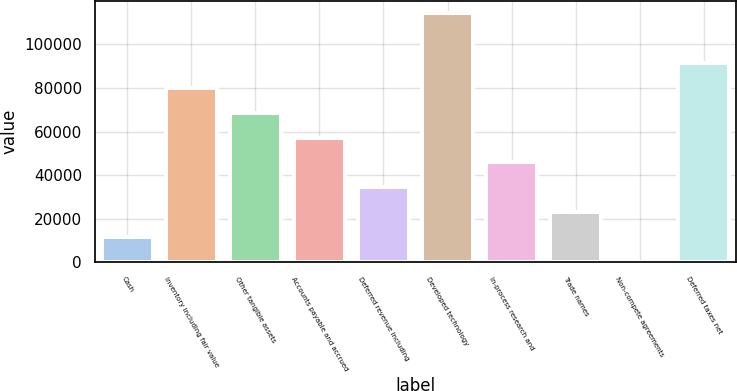Convert chart. <chart><loc_0><loc_0><loc_500><loc_500><bar_chart><fcel>Cash<fcel>Inventory including fair value<fcel>Other tangible assets<fcel>Accounts payable and accrued<fcel>Deferred revenue including<fcel>Developed technology<fcel>In-process research and<fcel>Trade names<fcel>Non-compete agreements<fcel>Deferred taxes net<nl><fcel>11695.1<fcel>80065.7<fcel>68670.6<fcel>57275.5<fcel>34485.3<fcel>114251<fcel>45880.4<fcel>23090.2<fcel>300<fcel>91460.8<nl></chart> 